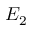<formula> <loc_0><loc_0><loc_500><loc_500>E _ { 2 }</formula> 